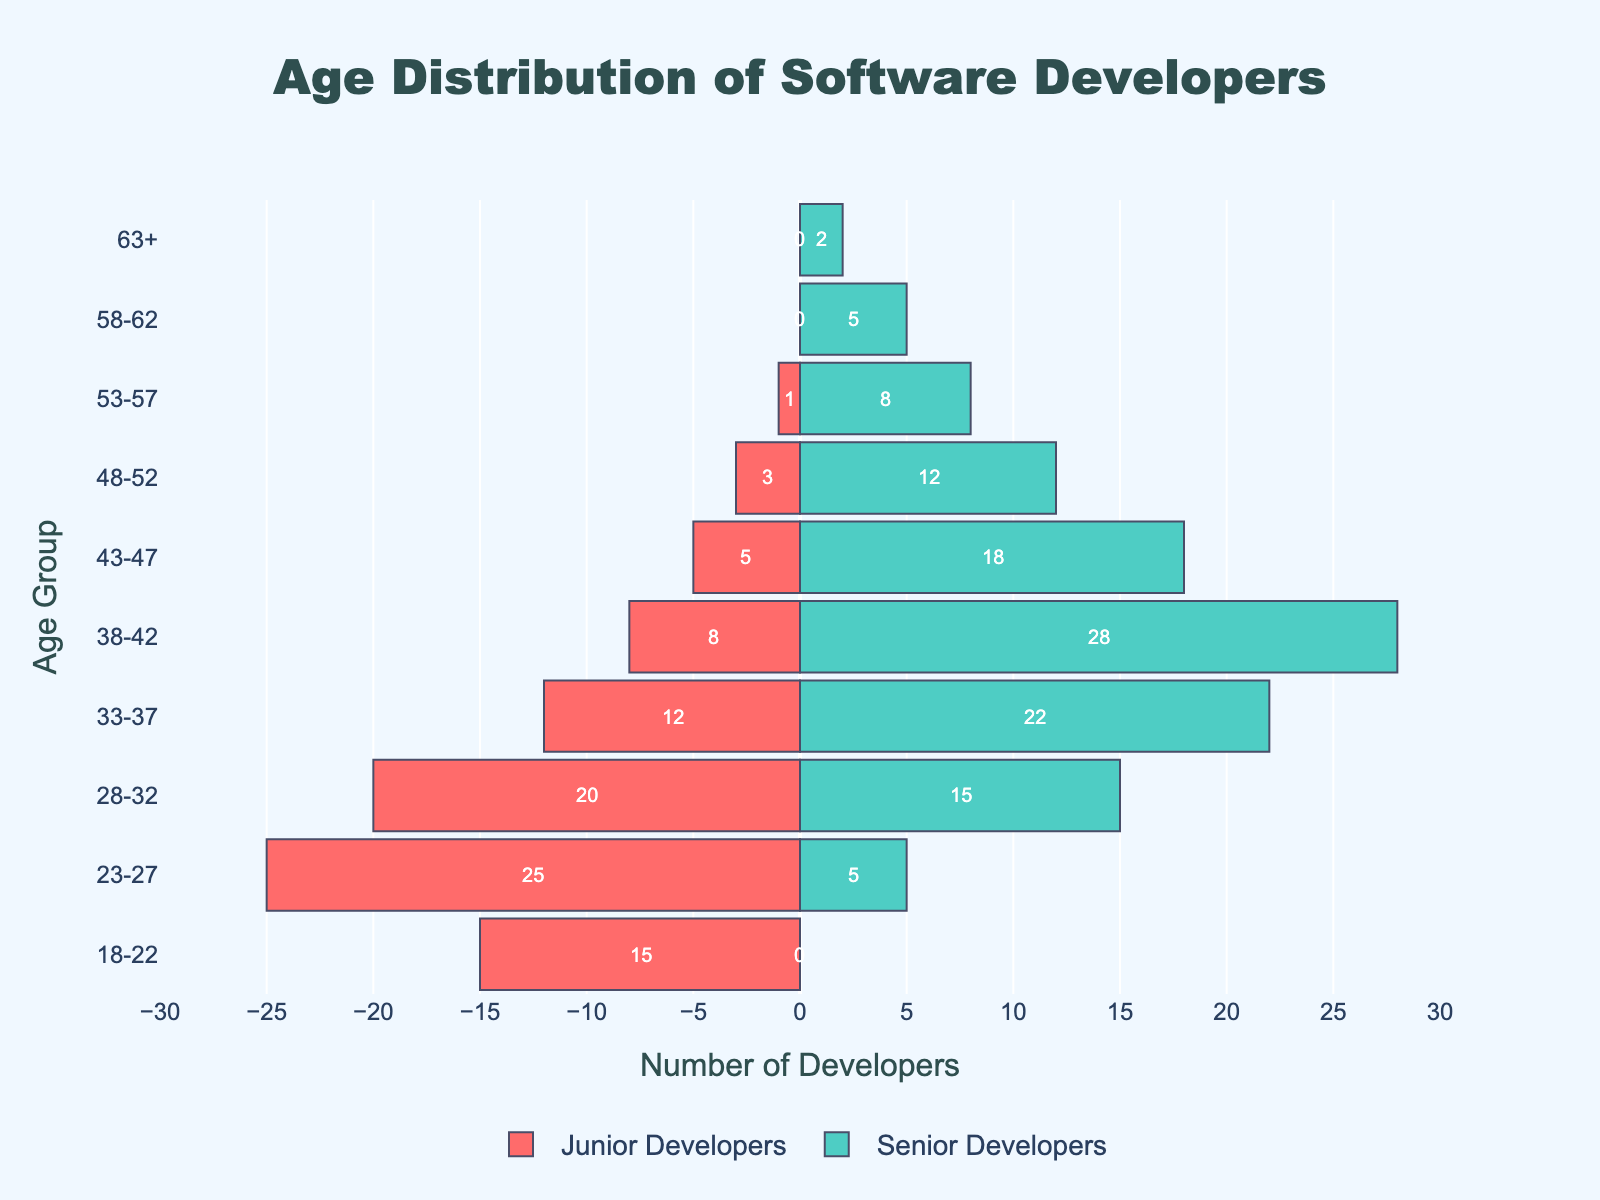What is the title of the figure? The title of the figure is usually found at the top and center. The title in this case reads 'Age Distribution of Software Developers', indicating the main subject of the plot.
Answer: Age Distribution of Software Developers How many age groups are represented in the figure? You can determine the number of age groups by counting the categories on the y-axis.
Answer: 10 Which age group has the highest number of junior developers? By comparing the lengths of the bars representing junior developers (in red), you can see that the 23-27 age group has the longest bar.
Answer: 23-27 What is the total number of senior developers in the 33-37 age group? You find the number of senior developers in the 33-37 age group by looking at the length of the bar for that group and considering the number annotated on it. The bar for senior developers in the 33-37 age group shows 22 developers.
Answer: 22 What is the difference in the number of developers between junior and senior developers for the 28-32 age group? For the 28-32 age group, subtract the number of senior developers (15) from the number of junior developers (20).
Answer: 5 Which age group has an equal count of junior and senior developers? By comparing both bars (red for juniors and green for seniors) across all age groups, there isn't any age group where the counts are equal.
Answer: None How does the number of junior developers in the 18-22 age group compare with the entire number of senior developers in age groups 58-62 and 63+ combined? The number of junior developers in the 18-22 age group is 15. The number of senior developers in the 58-62 group is 5, and in the 63+ group is 2. Adding these gives 5 + 2 = 7, which is less than 15.
Answer: More Which age group has the least number of developers in any category? By finding the bar with the shortest length and checking the numbers, the 63+ age group has the least number of developers with 2 senior developers and 0 junior developers.
Answer: 63+ What is the average number of junior developers across all age groups? Add the number of junior developers in all age groups (15 + 25 + 20 + 12 + 8 + 5 + 3 + 1 + 0 + 0 = 89) and divide by the number of age groups (10). The average is 89 / 10 = 8.9
Answer: 8.9 Which age group shows a significant transition from junior to senior developers? Look for age groups with a noticeable change in the count from junior to senior developers. The age group 38-42 shows a significant transition with junior developers decreasing to 8 and senior developers increasing to 28.
Answer: 38-42 